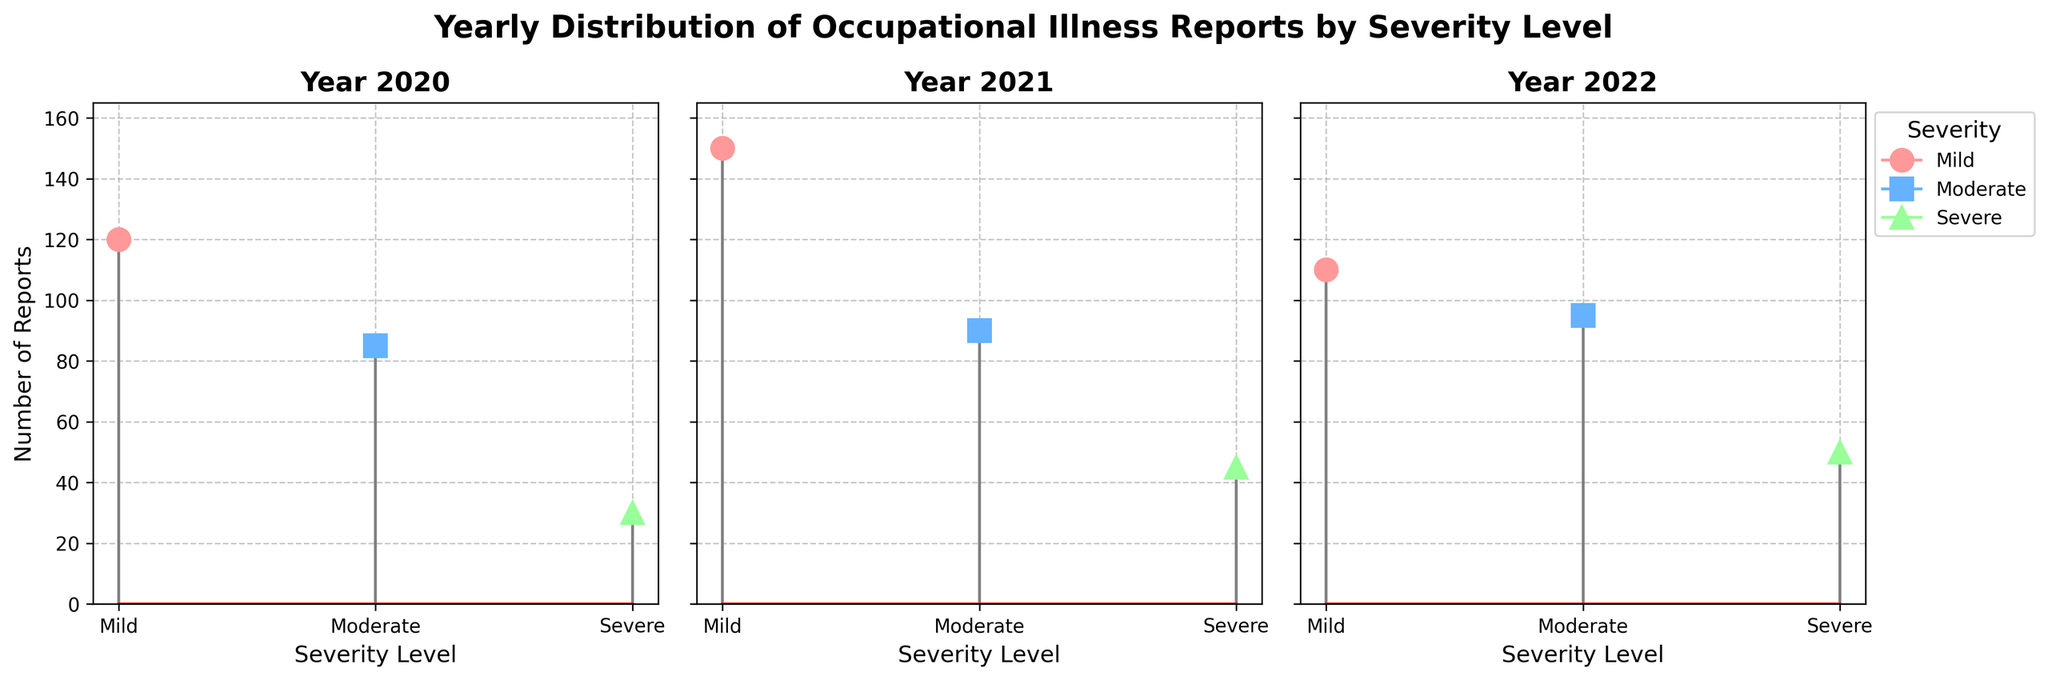What is the title of the figure? The title of the figure is displayed at the top center in bold and reads "Yearly Distribution of Occupational Illness Reports by Severity Level".
Answer: Yearly Distribution of Occupational Illness Reports by Severity Level Which year had the highest number of mild reports? From the three subplots, the 'Year 2021' subplot shows the highest stem for mild severity level reports.
Answer: 2021 What is the total number of reports for the year 2020? For 2020, sum the counts of each severity level: Mild (120) + Moderate (85) + Severe (30).
Answer: 235 How do the counts for severe cases compare across the years? By looking at the severe reports across the subplots, the counts are as follows: 2020 (30), 2021 (45), and 2022 (50). Thus, the numbers increased sequentially from 2020 to 2022.
Answer: Increase sequentially Which severity level had the highest number of reports in 2022? In the 2022 subplot, the mild severity level has the highest count (110) compared to moderate (95) and severe (50).
Answer: Mild Calculate the average number of moderate cases reported per year. Add the moderate case counts for all years: 85 (2020) + 90 (2021) + 95 (2022) and divide by the number of years, which is 3. (85 + 90 + 95) / 3 = 90.
Answer: 90 In which year did the mild cases decrease compared to the previous year? Comparing mild cases year by year: 2020 (120) to 2021 (150) increased, but 2021 (150) to 2022 (110) decreased.
Answer: 2022 Which subplot shows the highest total number of reports? Calculate the total number of reports for each subplot: 2020 (235), 2021 (285), and 2022 (255). The highest total is 2021.
Answer: 2021 What is the difference in the number of severe cases between 2021 and 2022? The difference between severe cases in 2021 (45) and 2022 (50) is 50 - 45.
Answer: 5 How many markers represent mild severity across all subplots? Each subplot (one for each year) has one marker for mild severity, so there are 3 subplots times 1 marker each = 3.
Answer: 3 